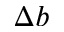Convert formula to latex. <formula><loc_0><loc_0><loc_500><loc_500>\Delta b</formula> 